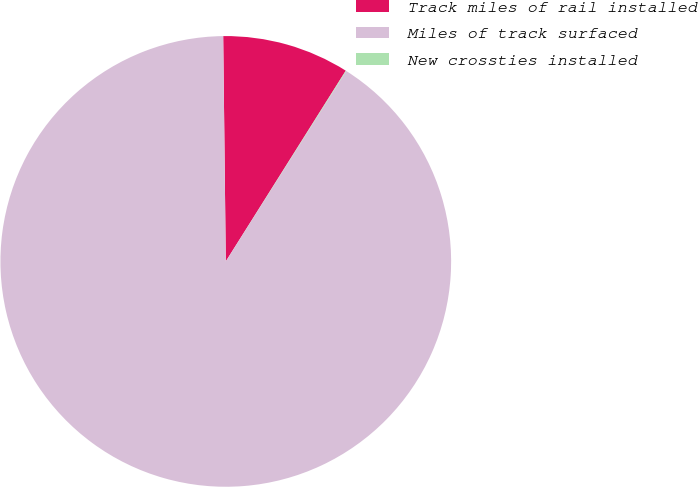<chart> <loc_0><loc_0><loc_500><loc_500><pie_chart><fcel>Track miles of rail installed<fcel>Miles of track surfaced<fcel>New crossties installed<nl><fcel>9.12%<fcel>90.84%<fcel>0.04%<nl></chart> 